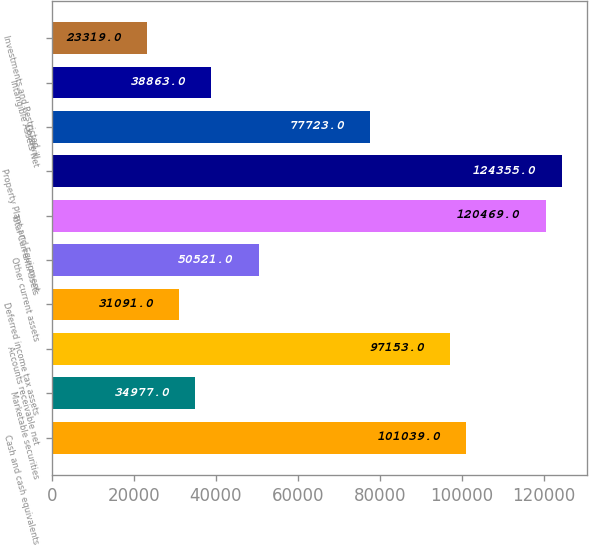Convert chart to OTSL. <chart><loc_0><loc_0><loc_500><loc_500><bar_chart><fcel>Cash and cash equivalents<fcel>Marketable securities<fcel>Accounts receivable net<fcel>Deferred income tax assets<fcel>Other current assets<fcel>Total Current Assets<fcel>Property Plant and Equipment<fcel>Goodwill<fcel>Intangible Assets Net<fcel>Investments and Restricted<nl><fcel>101039<fcel>34977<fcel>97153<fcel>31091<fcel>50521<fcel>120469<fcel>124355<fcel>77723<fcel>38863<fcel>23319<nl></chart> 